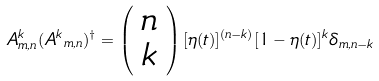Convert formula to latex. <formula><loc_0><loc_0><loc_500><loc_500>A ^ { k } _ { m , n } ( { A ^ { k } } _ { m , n } ) ^ { \dagger } = \left ( \begin{array} { c } n \\ k \end{array} \right ) [ \eta ( t ) ] ^ { ( n - k ) } [ 1 - \eta ( t ) ] ^ { k } \delta _ { m , n - k }</formula> 